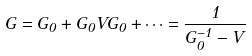Convert formula to latex. <formula><loc_0><loc_0><loc_500><loc_500>G = G _ { 0 } + G _ { 0 } V G _ { 0 } + \cdots = \frac { 1 } { G _ { 0 } ^ { - 1 } - V }</formula> 